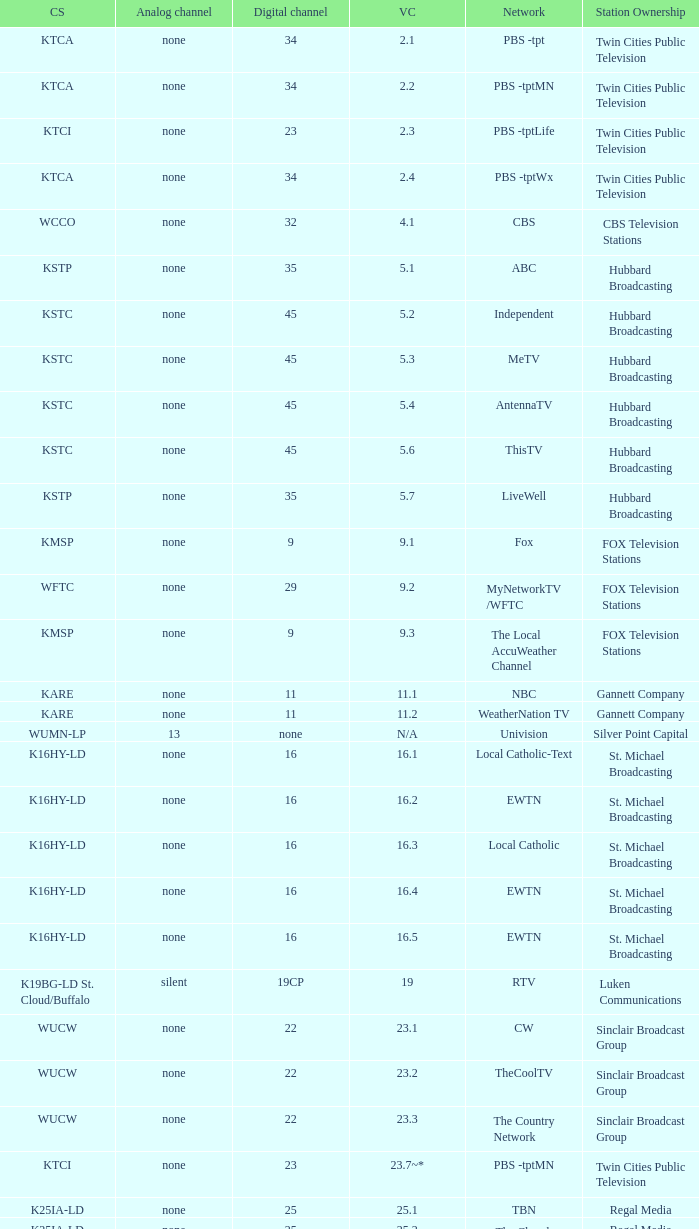Network of nbc is what digital channel? 11.0. 